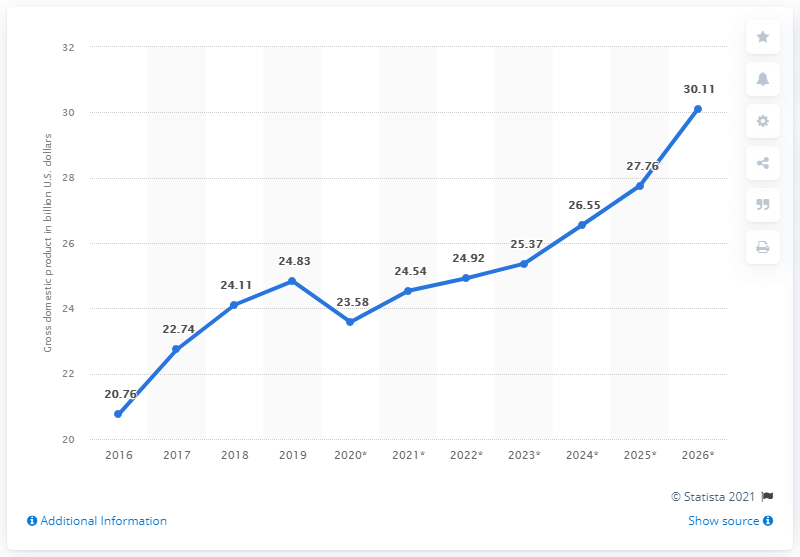Outline some significant characteristics in this image. In 2019, the gross domestic product of Papua New Guinea was 24.92. 